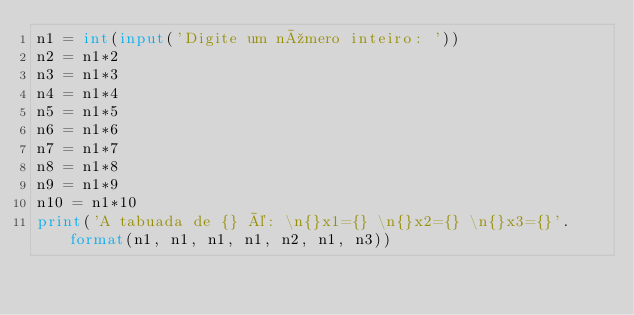Convert code to text. <code><loc_0><loc_0><loc_500><loc_500><_Python_>n1 = int(input('Digite um número inteiro: '))
n2 = n1*2
n3 = n1*3
n4 = n1*4
n5 = n1*5
n6 = n1*6
n7 = n1*7
n8 = n1*8
n9 = n1*9
n10 = n1*10
print('A tabuada de {} é: \n{}x1={} \n{}x2={} \n{}x3={}'.format(n1, n1, n1, n1, n2, n1, n3))</code> 